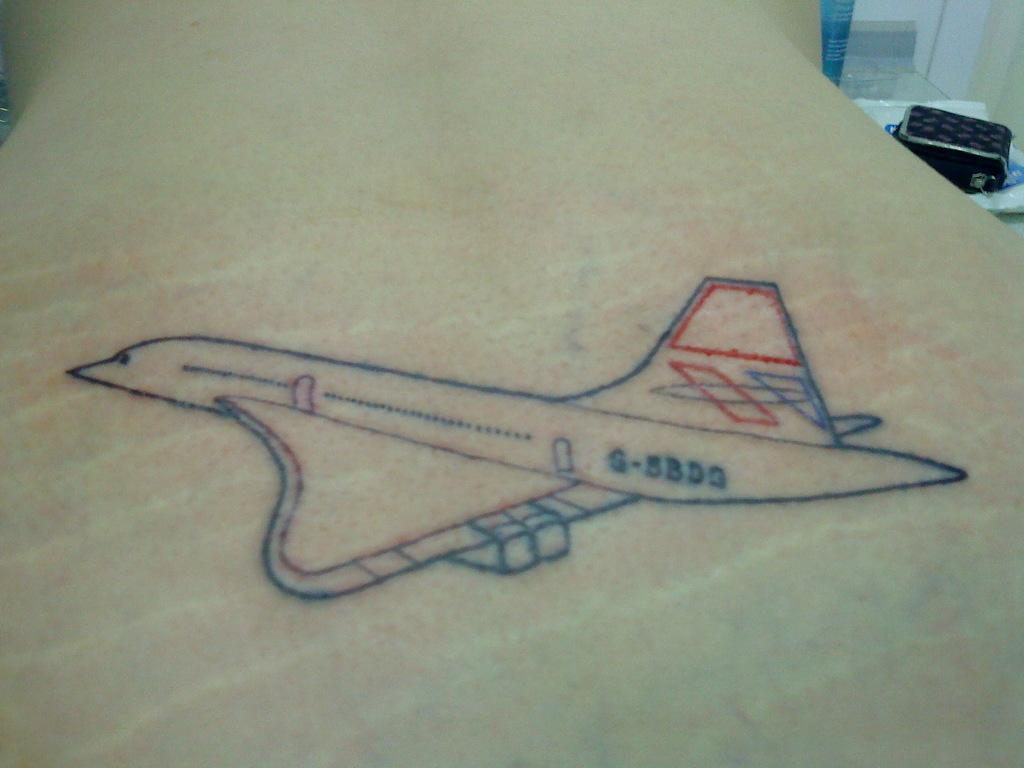Provide a one-sentence caption for the provided image. A Space Shuttle drawing includes the number G-5BD3 on it. 